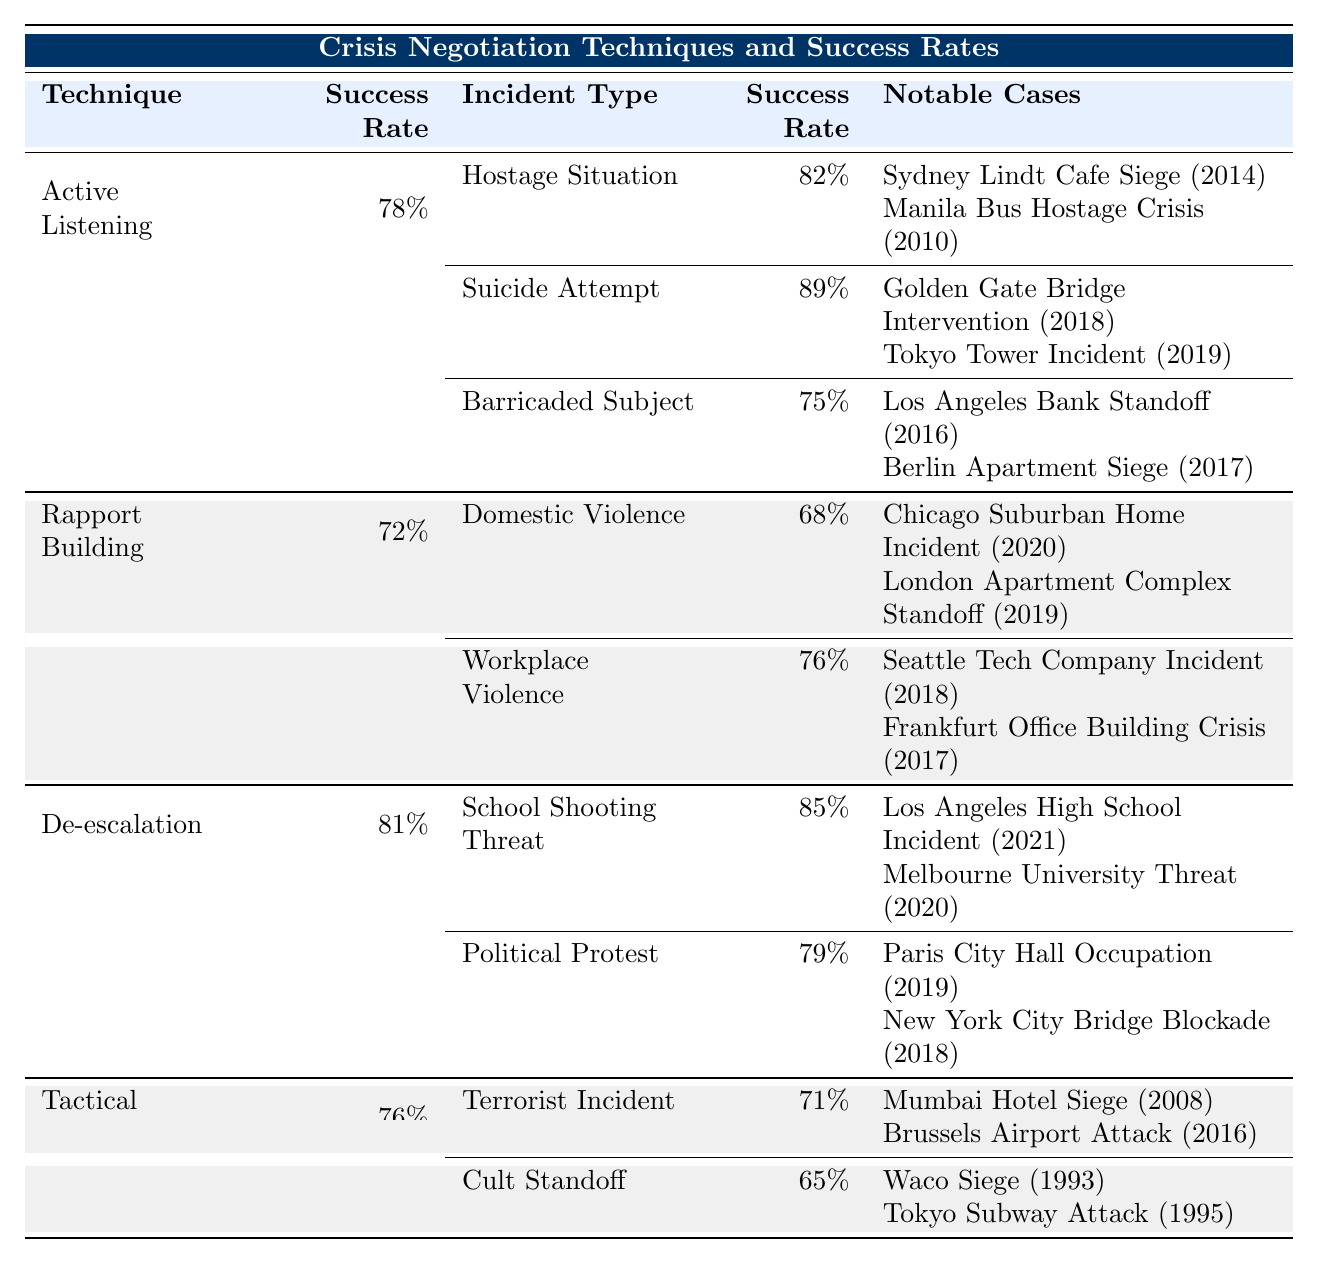What is the success rate for the Active Listening technique? According to the table, the success rate for the Active Listening technique is directly listed as 78%.
Answer: 78% Which incident type has the highest success rate under Active Listening? The table shows that under Active Listening, the incident type with the highest success rate is Suicide Attempt with 89%.
Answer: Suicide Attempt What is the notable case for the School Shooting Threat incident? The notable case for the School Shooting Threat incident, listed under the De-escalation technique, is the Los Angeles High School Incident (2021).
Answer: Los Angeles High School Incident (2021) What incident type has the lowest success rate under Rapport Building? The table indicates that the incident type with the lowest success rate under Rapport Building is Domestic Violence with 68%.
Answer: Domestic Violence What is the average success rate for incident types associated with De-escalation? The table lists two incident types for De-escalation: School Shooting Threat (85%) and Political Protest (79%). The average success rate is (85 + 79) / 2 = 82%.
Answer: 82% Is the success rate for Tactical Empathy in applications to Cult Standoff higher than that for Terrorist Incident? The success rate for Tactical Empathy in Cult Standoff is 65%, while for Terrorist Incident it is 71%. Since 71% is greater than 65%, the statement is false.
Answer: No Which negotiation technique has a better success rate overall, Active Listening or Tactical Empathy? Active Listening has a success rate of 78%, while Tactical Empathy has a success rate of 76%. Therefore, Active Listening has a better overall success rate compared to Tactical Empathy.
Answer: Active Listening For the incident type 'Hostage Situation', what is its success rate and notable case? The success rate for 'Hostage Situation' under Active Listening is 82%. A notable case listed is the Sydney Lindt Cafe Siege (2014).
Answer: 82%, Sydney Lindt Cafe Siege (2014) What is the difference in success rates between the Suicide Attempt and Barricaded Subject incident types under Active Listening? The success rate for Suicide Attempt is 89%, and for Barricaded Subject, it is 75%. The difference is 89% - 75% = 14%.
Answer: 14% Which technique should a negotiator prioritize if they want to focus on incident types with the highest general success rates? The technique with the highest overall success rate is De-escalation at 81% focusing on School Shooting Threat and Political Protest.
Answer: De-escalation 